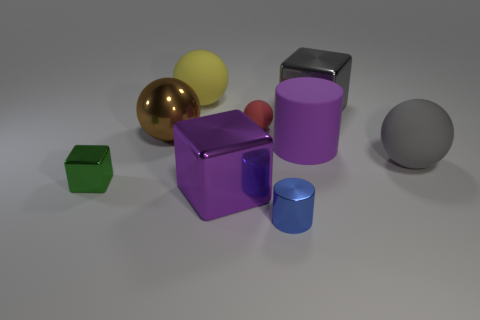Add 1 large gray metal things. How many objects exist? 10 Subtract all cubes. How many objects are left? 6 Add 3 large gray shiny blocks. How many large gray shiny blocks are left? 4 Add 8 rubber cylinders. How many rubber cylinders exist? 9 Subtract 0 red blocks. How many objects are left? 9 Subtract all tiny rubber balls. Subtract all large matte balls. How many objects are left? 6 